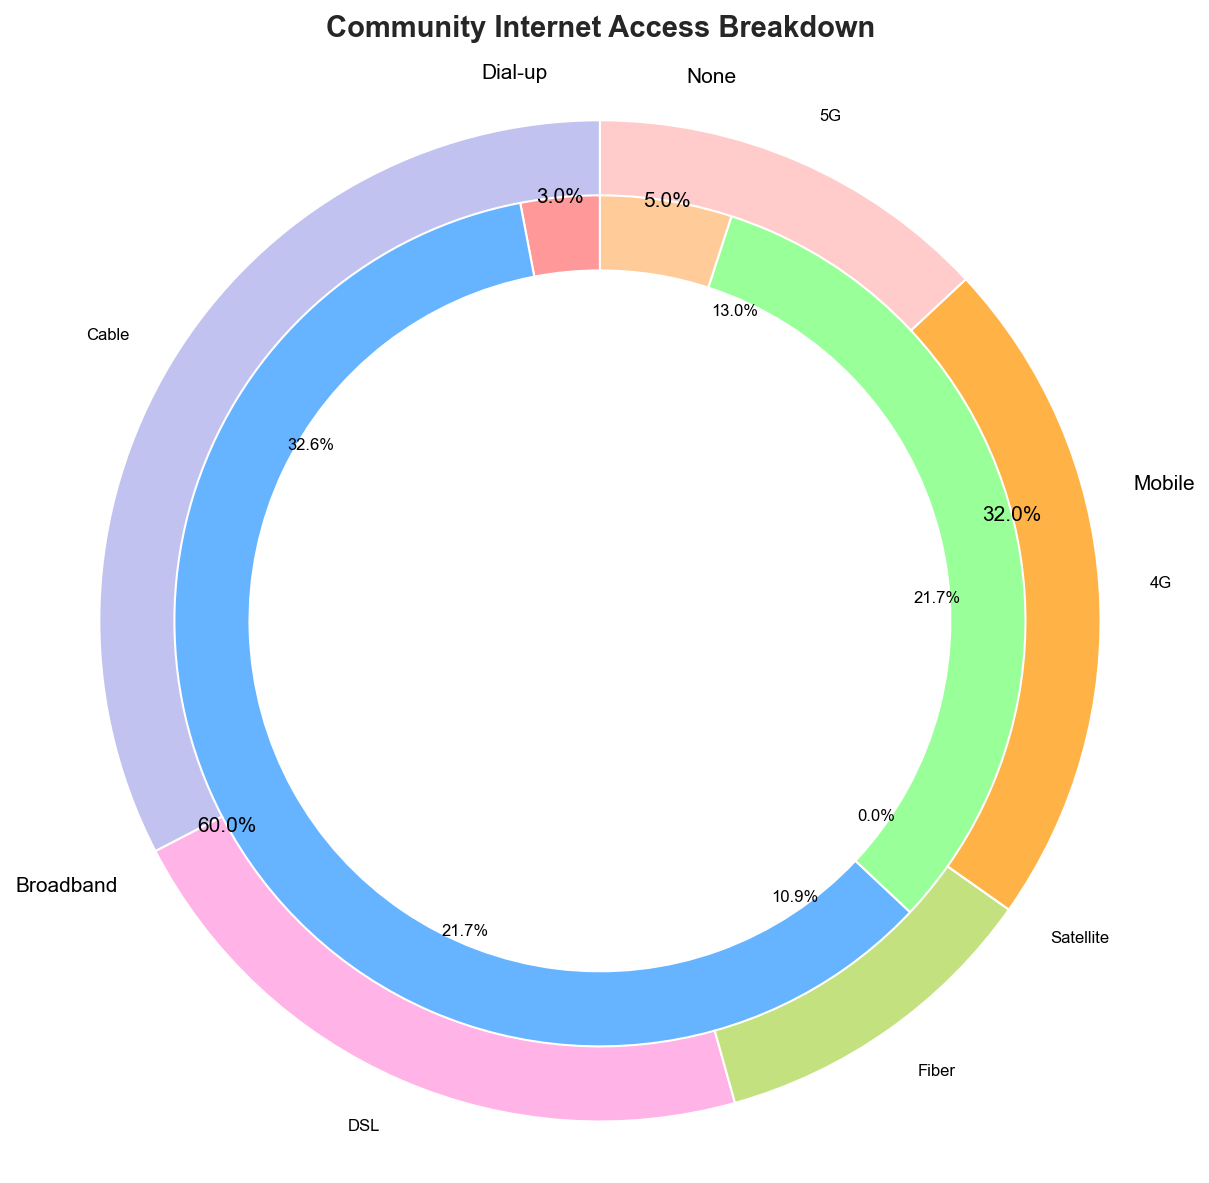What percentage of the community has no internet access? To find the percentage of the community without internet access, look at the "None" section of the outer pie chart. The figure indicates that this section is labeled with a percentage.
Answer: 5% Which type of internet access is most prevalent in the community? By observing the outer pie chart, identify which section has the largest size and percentage label. In this case, the "Broadband" section is the largest.
Answer: Broadband How do broadband and mobile internet usage compare in the community? Examine the outer pie chart and compare the sizes of the "Broadband" and "Mobile" sections. The percentage labels also indicate their respective sizes. Broadband is 60%, and Mobile is 32%.
Answer: Broadband is higher than Mobile What percentage of broadband users have cable internet? Look at the inner pie chart for the "Broadband" segment. The "Cable" section within this segment indicates the percentage of broadband users using cable internet.
Answer: 30% How does the percentage of 5G mobile users compare to DSL broadband users? Examine the inner pie chart for the "Mobile" and "Broadband" segments. Compare the size and labels of the "5G" section within Mobile and the "DSL" section within Broadband. 5G is 12%, and DSL is 20%.
Answer: 5G is less than DSL What is the combined percentage of internet access for both broadband and mobile? Add the percentages of the "Broadband" and "Mobile" sections from the outer pie chart. Broadband is 60%, and Mobile is 32%. The combined percentage is 60% + 32%.
Answer: 92% How many times more common is 4G internet than dial-up in the community? Compare the sizes of the "4G" section in the inner pie chart for Mobile and the "Dial-up" section in the outer pie chart. 4G is 20%, and Dial-up is 3%. Divide 20% by 3%.
Answer: Approximately 6.7 times How does the percentage of fiber broadband users compare to 4G mobile users? Look at the inner pie chart segments for "Broadband" (Fiber) and "Mobile" (4G). Compare the percentage labels; Fiber is 10%, while 4G is 20%.
Answer: Fiber is less than 4G What is the difference in usage between 4G and 5G mobile internet? Look at the inner pie chart for the "Mobile" section to find the percentages for "4G" and "5G". The difference between these values is 20% - 12%.
Answer: 8% 